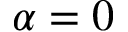<formula> <loc_0><loc_0><loc_500><loc_500>\alpha = 0</formula> 